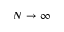Convert formula to latex. <formula><loc_0><loc_0><loc_500><loc_500>N \rightarrow \infty</formula> 